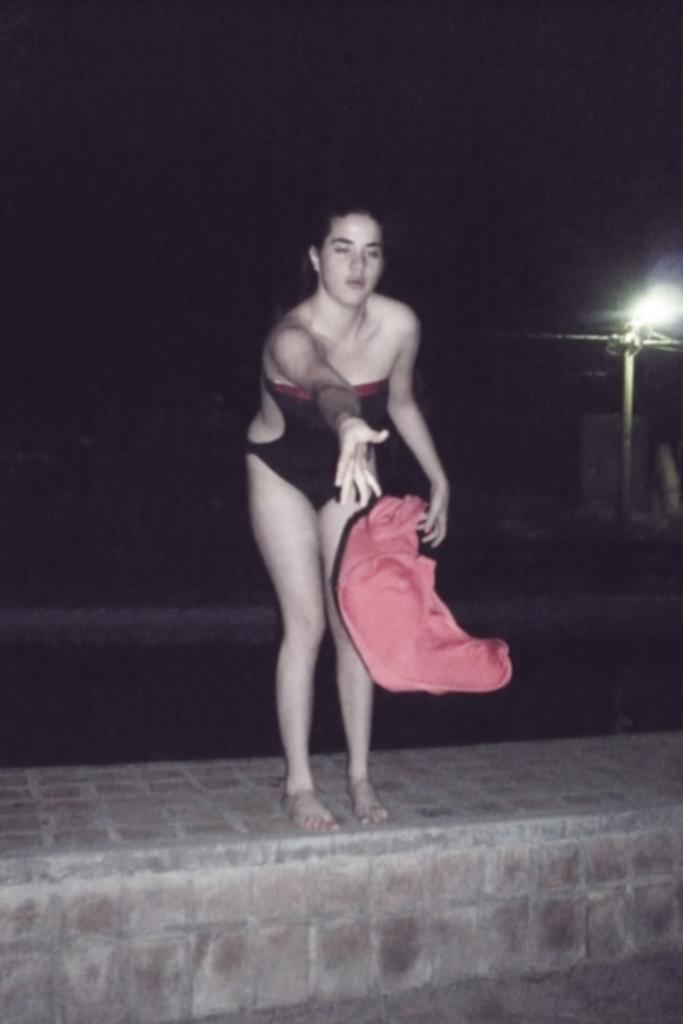Who is the main subject in the image? There is a woman in the image. What is the woman wearing? The woman is wearing a swimming dress. What action is the woman performing in the image? The woman is throwing an orange-colored cloth. Where is the woman standing in the image? The woman is standing on a brick wall. What can be observed about the background of the image? The background of the image is completely dark. What type of lunch is the maid preparing in the image? There is no maid or lunch present in the image. What territory is being claimed by the woman in the image? There is no indication of territory being claimed in the image; the woman is simply standing on a brick wall and throwing an orange-colored cloth. 